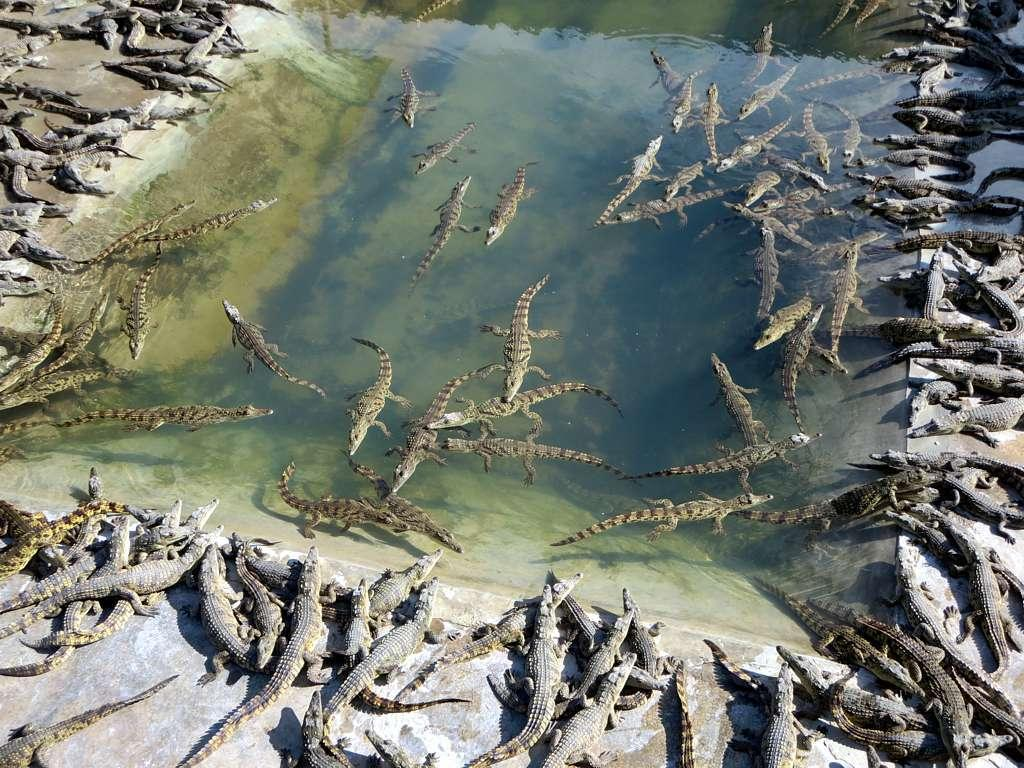What type of animals are in the image? There are crocodiles in the image. Where are the crocodiles located in the image? The crocodiles are in water and on land. What language are the crocodiles speaking in the image? Crocodiles do not speak any language, so this question cannot be answered definitively from the image. 